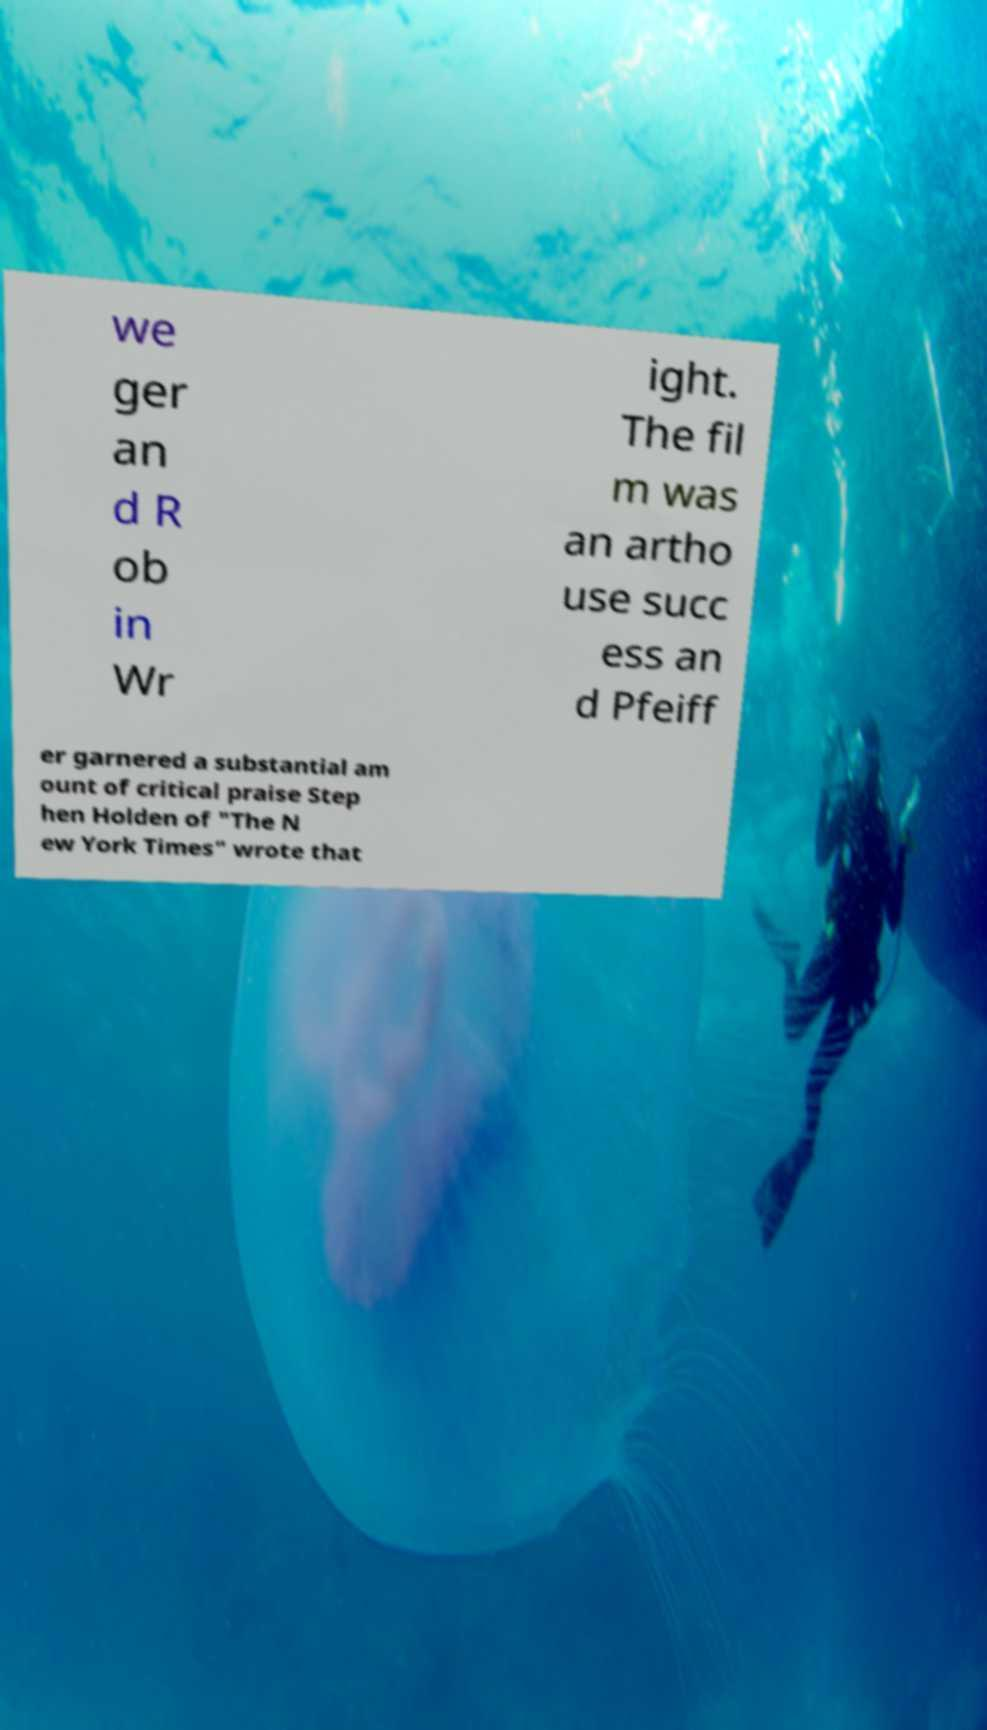Could you assist in decoding the text presented in this image and type it out clearly? we ger an d R ob in Wr ight. The fil m was an artho use succ ess an d Pfeiff er garnered a substantial am ount of critical praise Step hen Holden of "The N ew York Times" wrote that 